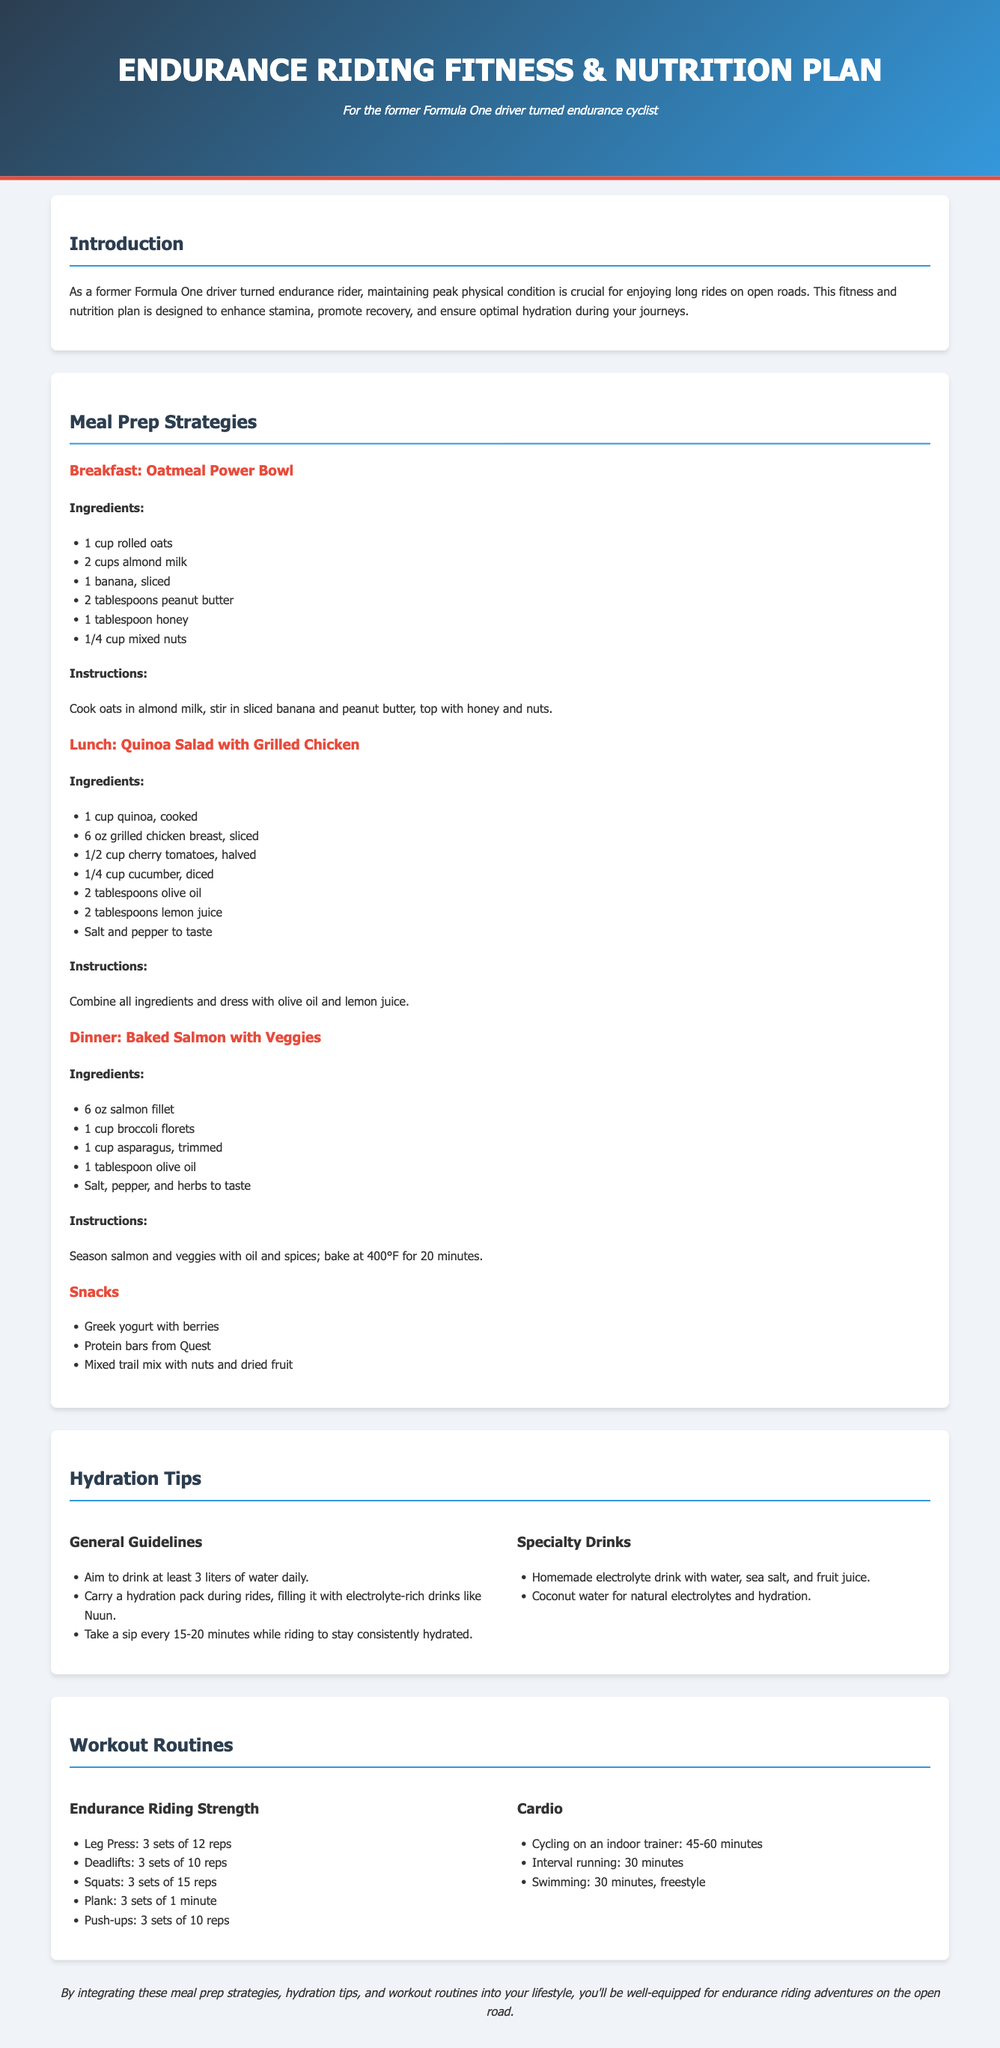What is the title of the document? The title of the document is found in the header section and represents the main focus of the content, which is "Endurance Riding Fitness & Nutrition Plan."
Answer: Endurance Riding Fitness & Nutrition Plan How many liters of water should you aim to drink daily? The hydration tips section specifies that one should aim to drink at least 3 liters of water daily, providing clear guidelines for hydration.
Answer: 3 liters What is the main ingredient in the Breakfast meal? The first meal listed, "Oatmeal Power Bowl," indicates that rolled oats are the primary ingredient, thus highlighting its importance in the recipe.
Answer: Rolled oats What type of fish is included in the dinner recipe? The dinner meal, "Baked Salmon with Veggies," directly refers to salmon as the fish used, indicating its nutritional presence in the meal.
Answer: Salmon How long should the indoor cycling session last? Under the workout routines, the suggested duration for cycling on an indoor trainer is 45-60 minutes, making it a specific recommendation for workout planning.
Answer: 45-60 minutes What type of drink does the "General Guidelines" section suggest carrying during rides? The hydration tips recommend carrying a hydration pack filled with electrolyte-rich drinks for optimal hydration while riding.
Answer: Electrolyte-rich drinks What is the preparation time for the Baked Salmon? Although not explicitly mentioned, the instructions for baking indicate a time of 20 minutes, which is essential for meal planning.
Answer: 20 minutes How many sets are recommended for the Leg Press exercise? The workout routines specify that the Leg Press exercise should be performed for 3 sets, indicating a structured workout approach.
Answer: 3 sets 